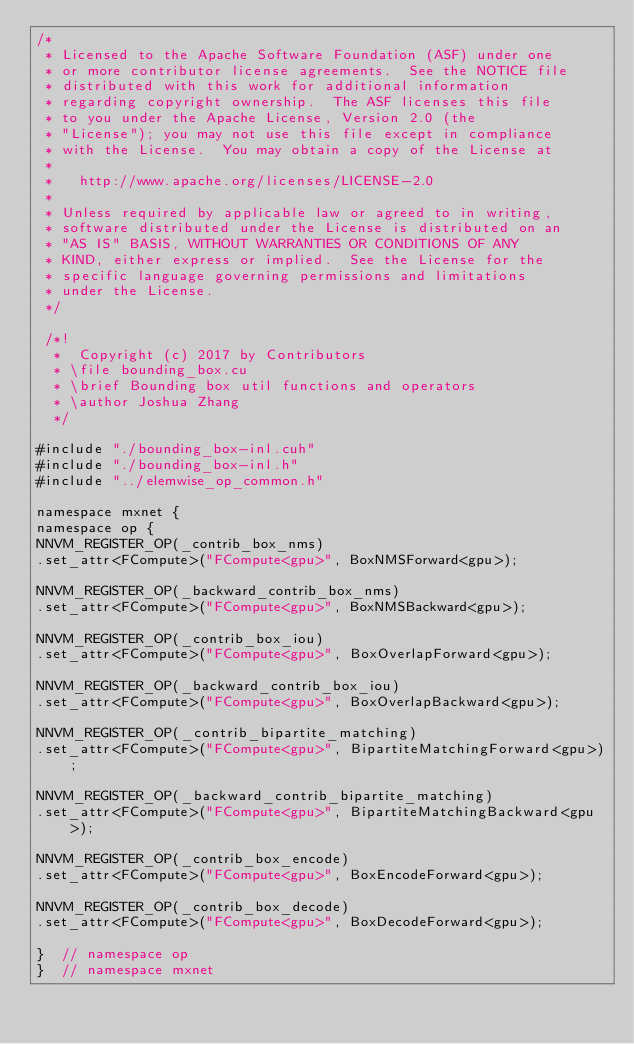<code> <loc_0><loc_0><loc_500><loc_500><_Cuda_>/*
 * Licensed to the Apache Software Foundation (ASF) under one
 * or more contributor license agreements.  See the NOTICE file
 * distributed with this work for additional information
 * regarding copyright ownership.  The ASF licenses this file
 * to you under the Apache License, Version 2.0 (the
 * "License"); you may not use this file except in compliance
 * with the License.  You may obtain a copy of the License at
 *
 *   http://www.apache.org/licenses/LICENSE-2.0
 *
 * Unless required by applicable law or agreed to in writing,
 * software distributed under the License is distributed on an
 * "AS IS" BASIS, WITHOUT WARRANTIES OR CONDITIONS OF ANY
 * KIND, either express or implied.  See the License for the
 * specific language governing permissions and limitations
 * under the License.
 */

 /*!
  *  Copyright (c) 2017 by Contributors
  * \file bounding_box.cu
  * \brief Bounding box util functions and operators
  * \author Joshua Zhang
  */

#include "./bounding_box-inl.cuh"
#include "./bounding_box-inl.h"
#include "../elemwise_op_common.h"

namespace mxnet {
namespace op {
NNVM_REGISTER_OP(_contrib_box_nms)
.set_attr<FCompute>("FCompute<gpu>", BoxNMSForward<gpu>);

NNVM_REGISTER_OP(_backward_contrib_box_nms)
.set_attr<FCompute>("FCompute<gpu>", BoxNMSBackward<gpu>);

NNVM_REGISTER_OP(_contrib_box_iou)
.set_attr<FCompute>("FCompute<gpu>", BoxOverlapForward<gpu>);

NNVM_REGISTER_OP(_backward_contrib_box_iou)
.set_attr<FCompute>("FCompute<gpu>", BoxOverlapBackward<gpu>);

NNVM_REGISTER_OP(_contrib_bipartite_matching)
.set_attr<FCompute>("FCompute<gpu>", BipartiteMatchingForward<gpu>);

NNVM_REGISTER_OP(_backward_contrib_bipartite_matching)
.set_attr<FCompute>("FCompute<gpu>", BipartiteMatchingBackward<gpu>);

NNVM_REGISTER_OP(_contrib_box_encode)
.set_attr<FCompute>("FCompute<gpu>", BoxEncodeForward<gpu>);

NNVM_REGISTER_OP(_contrib_box_decode)
.set_attr<FCompute>("FCompute<gpu>", BoxDecodeForward<gpu>);

}  // namespace op
}  // namespace mxnet
</code> 